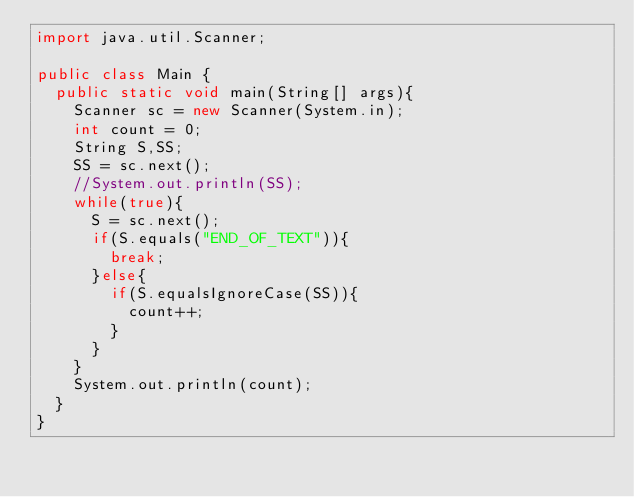<code> <loc_0><loc_0><loc_500><loc_500><_Java_>import java.util.Scanner;

public class Main {
  public static void main(String[] args){
    Scanner sc = new Scanner(System.in);
    int count = 0;
    String S,SS;
    SS = sc.next();
    //System.out.println(SS);
    while(true){
      S = sc.next();
      if(S.equals("END_OF_TEXT")){
        break;
      }else{
        if(S.equalsIgnoreCase(SS)){
          count++;
        }
      } 
    }
    System.out.println(count);
  }
}
</code> 